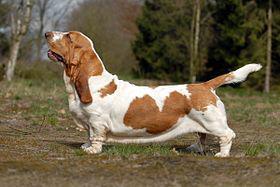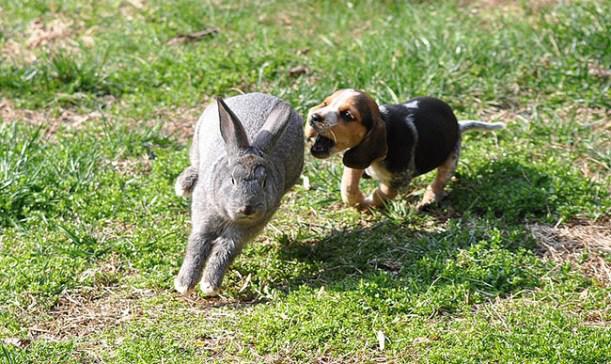The first image is the image on the left, the second image is the image on the right. Analyze the images presented: Is the assertion "Each image includes at least one horse and multiple beagles, and at least one image includes a rider wearing red." valid? Answer yes or no. No. The first image is the image on the left, the second image is the image on the right. Analyze the images presented: Is the assertion "People in coats are riding horses with several dogs in the image on the left." valid? Answer yes or no. No. 